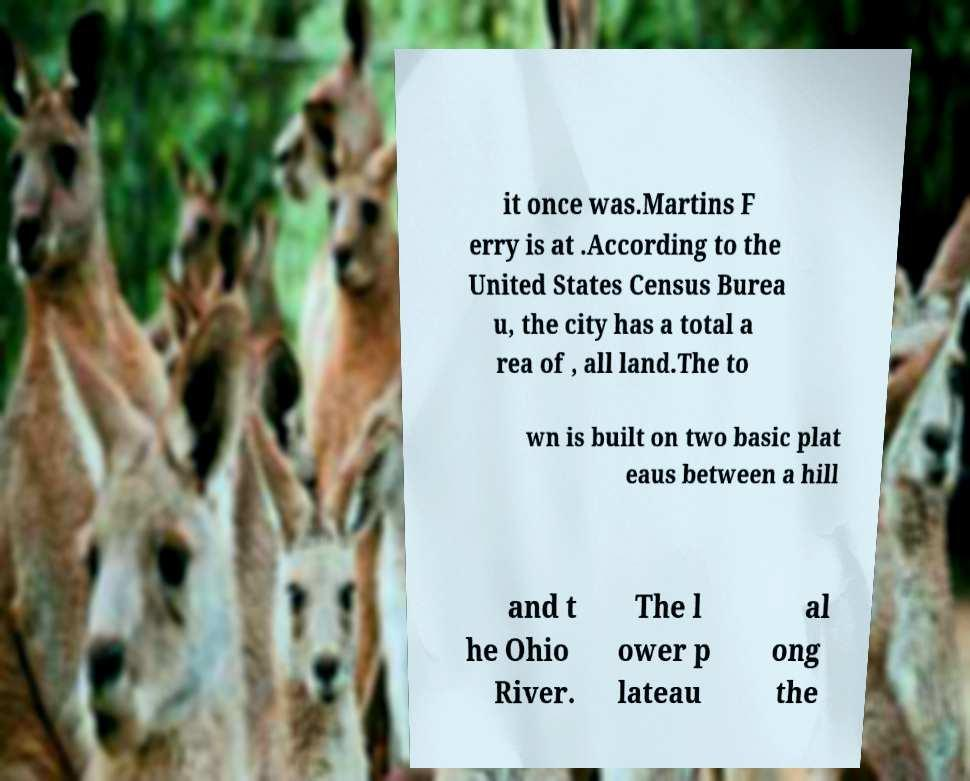For documentation purposes, I need the text within this image transcribed. Could you provide that? it once was.Martins F erry is at .According to the United States Census Burea u, the city has a total a rea of , all land.The to wn is built on two basic plat eaus between a hill and t he Ohio River. The l ower p lateau al ong the 